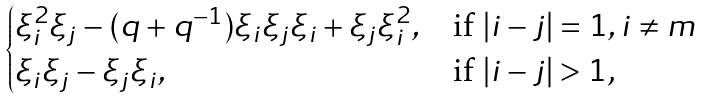Convert formula to latex. <formula><loc_0><loc_0><loc_500><loc_500>\begin{cases} \xi _ { i } ^ { 2 } \xi _ { j } - ( q + q ^ { - 1 } ) \xi _ { i } \xi _ { j } \xi _ { i } + \xi _ { j } \xi _ { i } ^ { 2 } , & \text {if $|i-j|=1,i\neq m$} \\ \xi _ { i } \xi _ { j } - \xi _ { j } \xi _ { i } , & \text {if $|i-j|>1$,} \end{cases}</formula> 